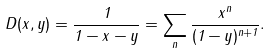<formula> <loc_0><loc_0><loc_500><loc_500>D ( x , y ) = \frac { 1 } { 1 - x - y } = \sum _ { n } \frac { x ^ { n } } { ( 1 - y ) ^ { n + 1 } } .</formula> 